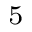<formula> <loc_0><loc_0><loc_500><loc_500>^ { 5 }</formula> 